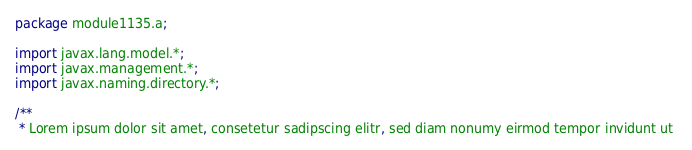<code> <loc_0><loc_0><loc_500><loc_500><_Java_>package module1135.a;

import javax.lang.model.*;
import javax.management.*;
import javax.naming.directory.*;

/**
 * Lorem ipsum dolor sit amet, consetetur sadipscing elitr, sed diam nonumy eirmod tempor invidunt ut </code> 